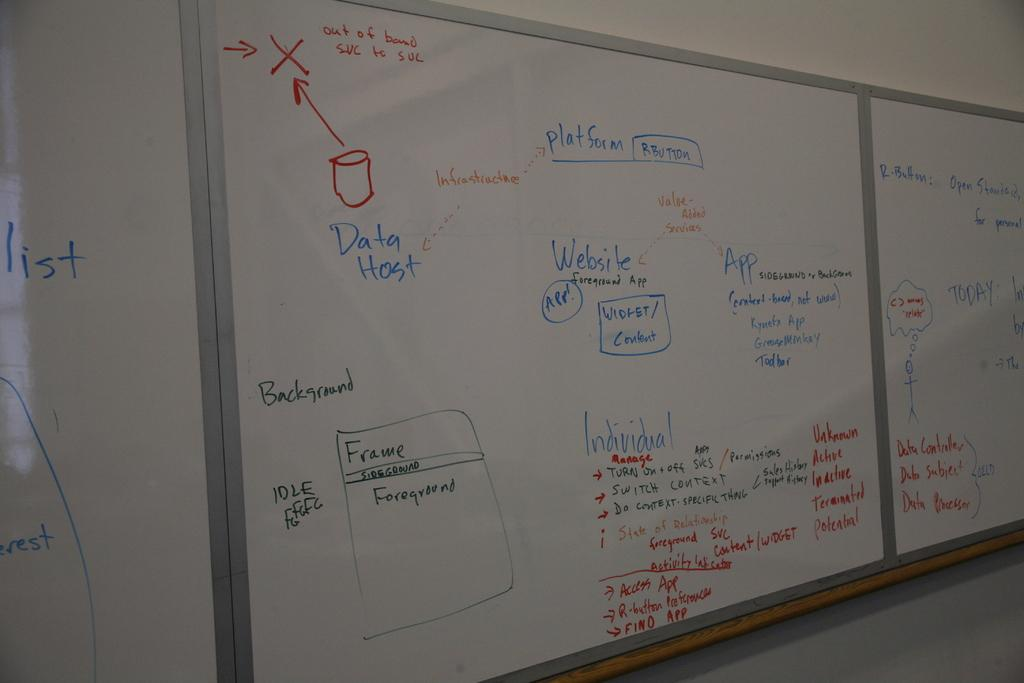<image>
Create a compact narrative representing the image presented. a white board with the word data host on it 